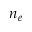Convert formula to latex. <formula><loc_0><loc_0><loc_500><loc_500>n _ { e }</formula> 